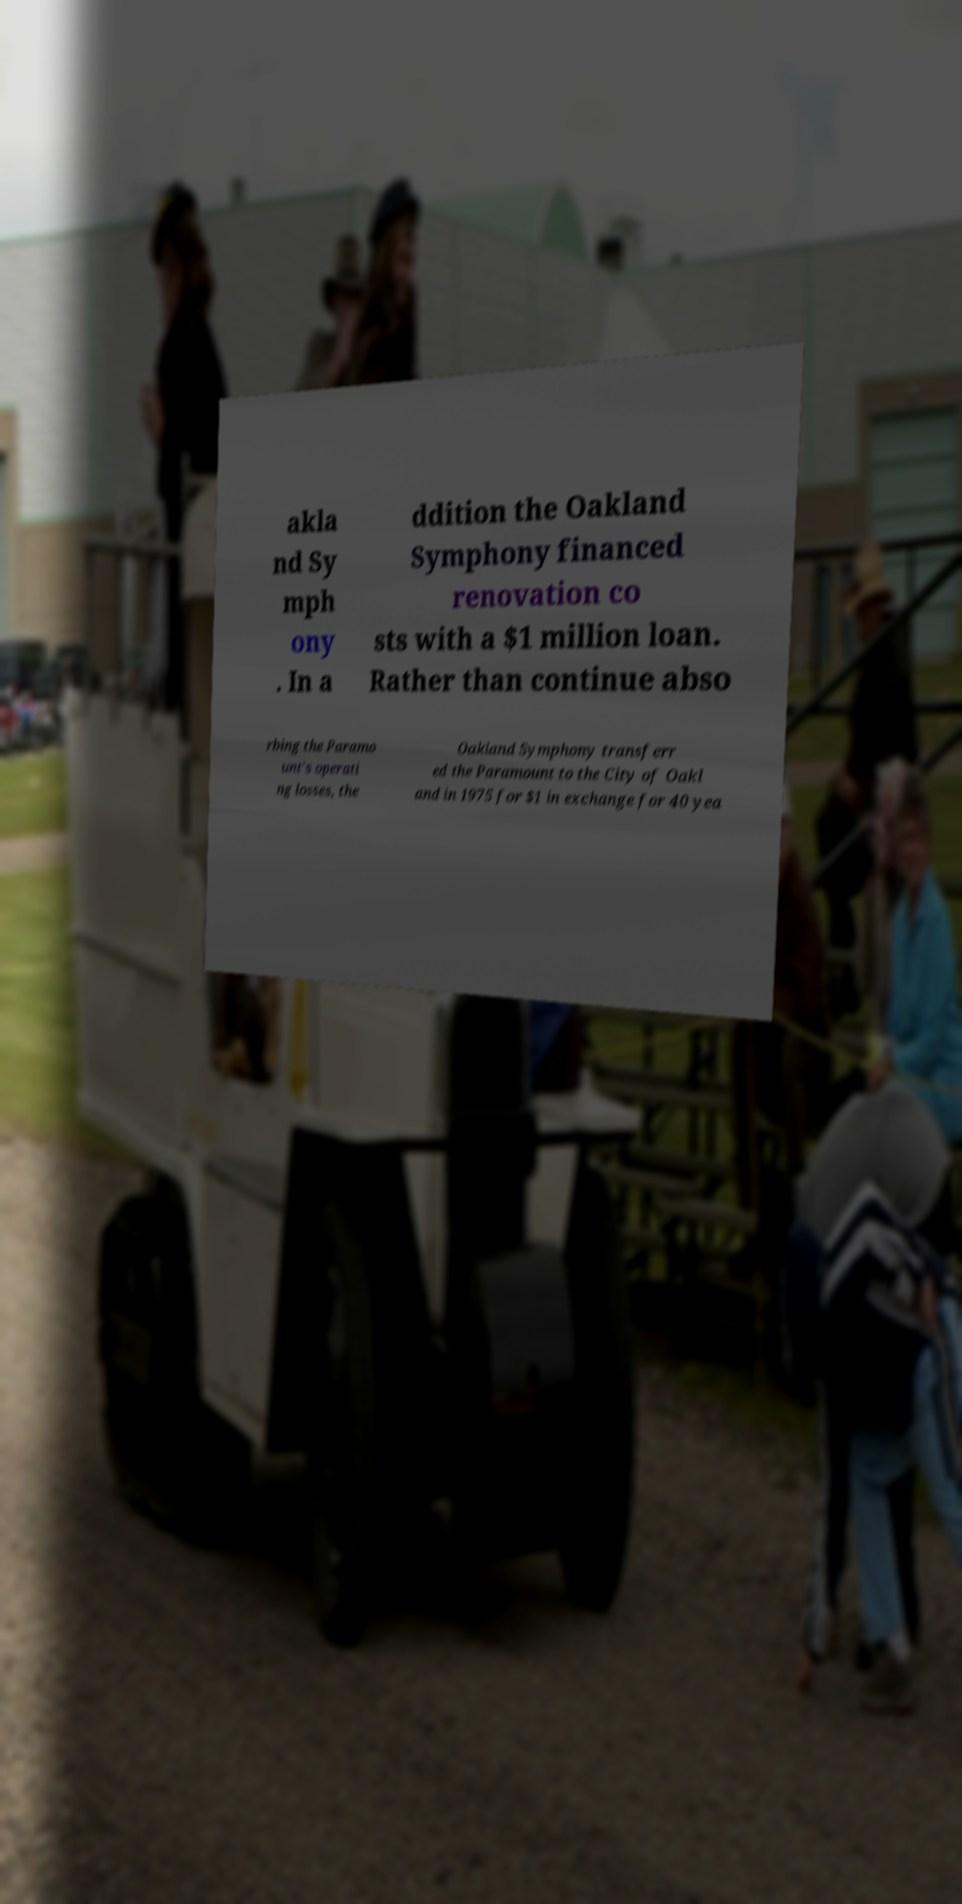Please identify and transcribe the text found in this image. akla nd Sy mph ony . In a ddition the Oakland Symphony financed renovation co sts with a $1 million loan. Rather than continue abso rbing the Paramo unt's operati ng losses, the Oakland Symphony transferr ed the Paramount to the City of Oakl and in 1975 for $1 in exchange for 40 yea 